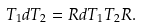Convert formula to latex. <formula><loc_0><loc_0><loc_500><loc_500>T _ { 1 } d T _ { 2 } = R d T _ { 1 } T _ { 2 } R .</formula> 